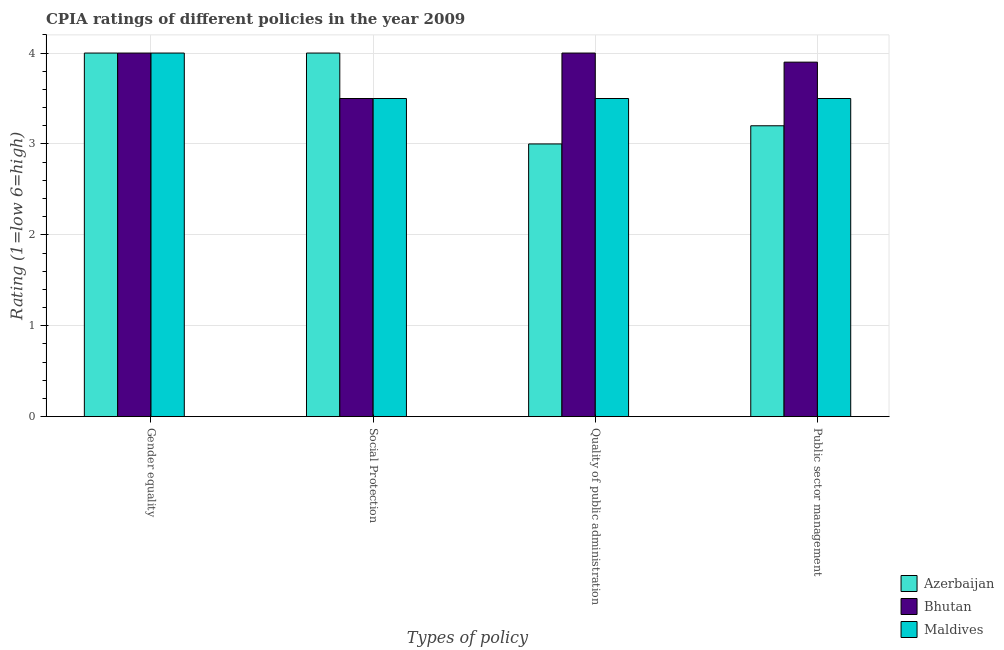Are the number of bars on each tick of the X-axis equal?
Your answer should be compact. Yes. How many bars are there on the 3rd tick from the right?
Ensure brevity in your answer.  3. What is the label of the 1st group of bars from the left?
Provide a succinct answer. Gender equality. What is the cpia rating of public sector management in Bhutan?
Ensure brevity in your answer.  3.9. Across all countries, what is the maximum cpia rating of gender equality?
Keep it short and to the point. 4. In which country was the cpia rating of quality of public administration maximum?
Make the answer very short. Bhutan. In which country was the cpia rating of public sector management minimum?
Provide a succinct answer. Azerbaijan. What is the total cpia rating of social protection in the graph?
Your response must be concise. 11. What is the difference between the cpia rating of public sector management in Bhutan and that in Azerbaijan?
Your answer should be compact. 0.7. Is the cpia rating of quality of public administration in Azerbaijan less than that in Maldives?
Your answer should be compact. Yes. Is the difference between the cpia rating of social protection in Maldives and Bhutan greater than the difference between the cpia rating of quality of public administration in Maldives and Bhutan?
Make the answer very short. Yes. What is the difference between the highest and the second highest cpia rating of quality of public administration?
Your answer should be very brief. 0.5. What is the difference between the highest and the lowest cpia rating of gender equality?
Make the answer very short. 0. What does the 1st bar from the left in Gender equality represents?
Keep it short and to the point. Azerbaijan. What does the 1st bar from the right in Public sector management represents?
Give a very brief answer. Maldives. How many bars are there?
Give a very brief answer. 12. Are all the bars in the graph horizontal?
Offer a terse response. No. How many countries are there in the graph?
Ensure brevity in your answer.  3. What is the difference between two consecutive major ticks on the Y-axis?
Your answer should be compact. 1. What is the title of the graph?
Provide a short and direct response. CPIA ratings of different policies in the year 2009. What is the label or title of the X-axis?
Provide a short and direct response. Types of policy. What is the label or title of the Y-axis?
Offer a very short reply. Rating (1=low 6=high). What is the Rating (1=low 6=high) of Bhutan in Gender equality?
Ensure brevity in your answer.  4. What is the Rating (1=low 6=high) of Bhutan in Social Protection?
Provide a succinct answer. 3.5. What is the Rating (1=low 6=high) of Maldives in Social Protection?
Give a very brief answer. 3.5. What is the Rating (1=low 6=high) of Bhutan in Quality of public administration?
Provide a succinct answer. 4. Across all Types of policy, what is the maximum Rating (1=low 6=high) of Bhutan?
Your answer should be compact. 4. What is the difference between the Rating (1=low 6=high) in Maldives in Gender equality and that in Social Protection?
Make the answer very short. 0.5. What is the difference between the Rating (1=low 6=high) of Azerbaijan in Gender equality and that in Public sector management?
Provide a succinct answer. 0.8. What is the difference between the Rating (1=low 6=high) in Azerbaijan in Social Protection and that in Quality of public administration?
Offer a terse response. 1. What is the difference between the Rating (1=low 6=high) in Bhutan in Social Protection and that in Public sector management?
Your answer should be compact. -0.4. What is the difference between the Rating (1=low 6=high) in Maldives in Quality of public administration and that in Public sector management?
Provide a short and direct response. 0. What is the difference between the Rating (1=low 6=high) in Azerbaijan in Gender equality and the Rating (1=low 6=high) in Maldives in Social Protection?
Offer a very short reply. 0.5. What is the difference between the Rating (1=low 6=high) of Bhutan in Gender equality and the Rating (1=low 6=high) of Maldives in Social Protection?
Keep it short and to the point. 0.5. What is the difference between the Rating (1=low 6=high) of Azerbaijan in Gender equality and the Rating (1=low 6=high) of Maldives in Public sector management?
Keep it short and to the point. 0.5. What is the difference between the Rating (1=low 6=high) of Azerbaijan in Social Protection and the Rating (1=low 6=high) of Bhutan in Quality of public administration?
Your response must be concise. 0. What is the difference between the Rating (1=low 6=high) in Azerbaijan in Social Protection and the Rating (1=low 6=high) in Maldives in Quality of public administration?
Make the answer very short. 0.5. What is the difference between the Rating (1=low 6=high) of Azerbaijan in Quality of public administration and the Rating (1=low 6=high) of Bhutan in Public sector management?
Your answer should be compact. -0.9. What is the difference between the Rating (1=low 6=high) in Azerbaijan in Quality of public administration and the Rating (1=low 6=high) in Maldives in Public sector management?
Give a very brief answer. -0.5. What is the average Rating (1=low 6=high) in Azerbaijan per Types of policy?
Your response must be concise. 3.55. What is the average Rating (1=low 6=high) in Bhutan per Types of policy?
Your answer should be very brief. 3.85. What is the average Rating (1=low 6=high) in Maldives per Types of policy?
Provide a succinct answer. 3.62. What is the difference between the Rating (1=low 6=high) in Azerbaijan and Rating (1=low 6=high) in Bhutan in Gender equality?
Your answer should be compact. 0. What is the difference between the Rating (1=low 6=high) in Bhutan and Rating (1=low 6=high) in Maldives in Gender equality?
Provide a short and direct response. 0. What is the difference between the Rating (1=low 6=high) in Azerbaijan and Rating (1=low 6=high) in Maldives in Social Protection?
Give a very brief answer. 0.5. What is the difference between the Rating (1=low 6=high) of Bhutan and Rating (1=low 6=high) of Maldives in Social Protection?
Give a very brief answer. 0. What is the difference between the Rating (1=low 6=high) in Azerbaijan and Rating (1=low 6=high) in Bhutan in Quality of public administration?
Provide a succinct answer. -1. What is the difference between the Rating (1=low 6=high) of Azerbaijan and Rating (1=low 6=high) of Maldives in Quality of public administration?
Offer a terse response. -0.5. What is the difference between the Rating (1=low 6=high) in Bhutan and Rating (1=low 6=high) in Maldives in Quality of public administration?
Provide a succinct answer. 0.5. What is the difference between the Rating (1=low 6=high) in Azerbaijan and Rating (1=low 6=high) in Bhutan in Public sector management?
Your response must be concise. -0.7. What is the ratio of the Rating (1=low 6=high) of Bhutan in Gender equality to that in Social Protection?
Keep it short and to the point. 1.14. What is the ratio of the Rating (1=low 6=high) of Maldives in Gender equality to that in Social Protection?
Provide a succinct answer. 1.14. What is the ratio of the Rating (1=low 6=high) in Azerbaijan in Gender equality to that in Quality of public administration?
Offer a terse response. 1.33. What is the ratio of the Rating (1=low 6=high) of Azerbaijan in Gender equality to that in Public sector management?
Ensure brevity in your answer.  1.25. What is the ratio of the Rating (1=low 6=high) in Bhutan in Gender equality to that in Public sector management?
Provide a short and direct response. 1.03. What is the ratio of the Rating (1=low 6=high) of Maldives in Gender equality to that in Public sector management?
Make the answer very short. 1.14. What is the ratio of the Rating (1=low 6=high) in Bhutan in Social Protection to that in Quality of public administration?
Make the answer very short. 0.88. What is the ratio of the Rating (1=low 6=high) in Maldives in Social Protection to that in Quality of public administration?
Your answer should be very brief. 1. What is the ratio of the Rating (1=low 6=high) in Azerbaijan in Social Protection to that in Public sector management?
Provide a short and direct response. 1.25. What is the ratio of the Rating (1=low 6=high) in Bhutan in Social Protection to that in Public sector management?
Give a very brief answer. 0.9. What is the ratio of the Rating (1=low 6=high) of Maldives in Social Protection to that in Public sector management?
Provide a succinct answer. 1. What is the ratio of the Rating (1=low 6=high) of Bhutan in Quality of public administration to that in Public sector management?
Offer a very short reply. 1.03. What is the difference between the highest and the second highest Rating (1=low 6=high) in Azerbaijan?
Your answer should be compact. 0. What is the difference between the highest and the lowest Rating (1=low 6=high) of Azerbaijan?
Keep it short and to the point. 1. What is the difference between the highest and the lowest Rating (1=low 6=high) in Maldives?
Offer a terse response. 0.5. 